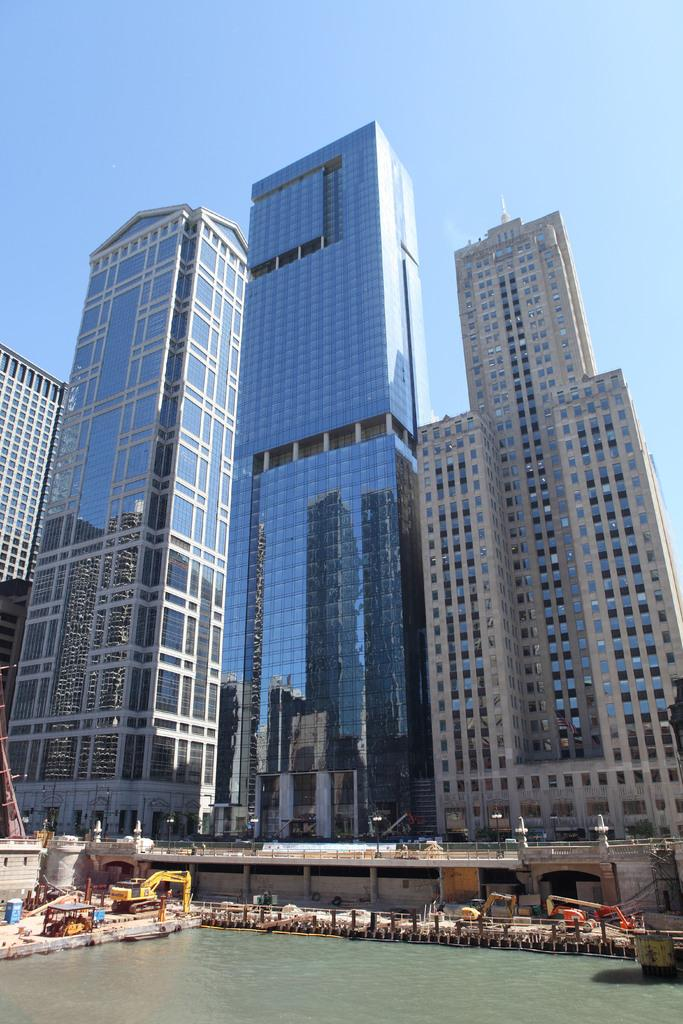What structures can be seen in the image? There are buildings in the image. What is visible in front of the buildings? There is water visible in front of the buildings. What type of steel is used to construct the buildings in the image? There is no information about the type of steel used in the construction of the buildings in the image. 